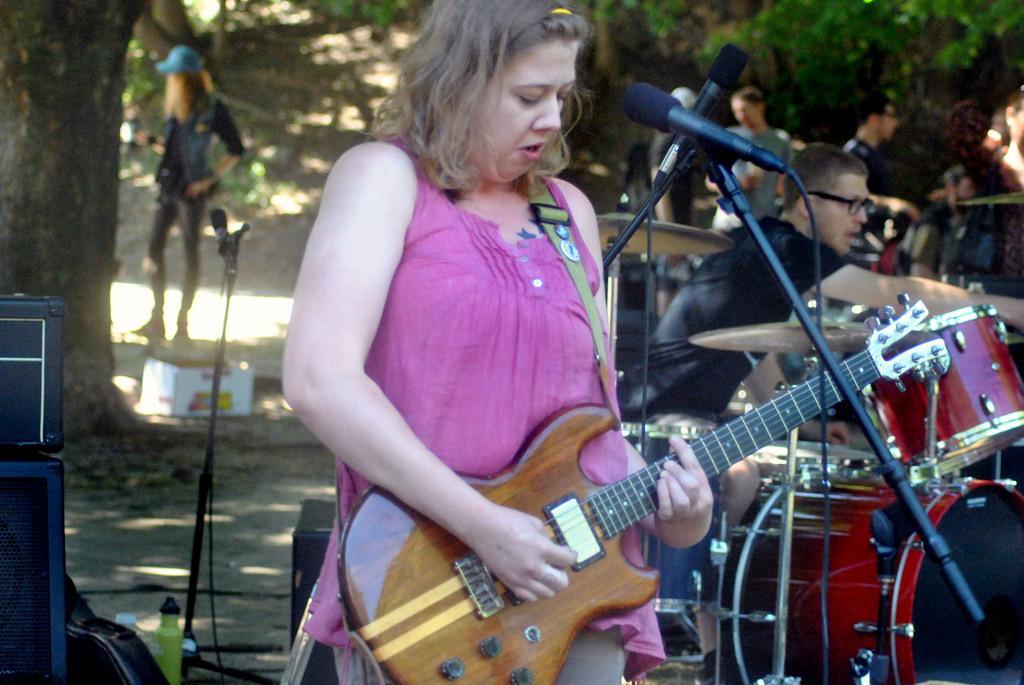Could you give a brief overview of what you see in this image? There is a woman holding a guitar singing on a microphone behind her there are so many other man playing musical instruments under a tree. 